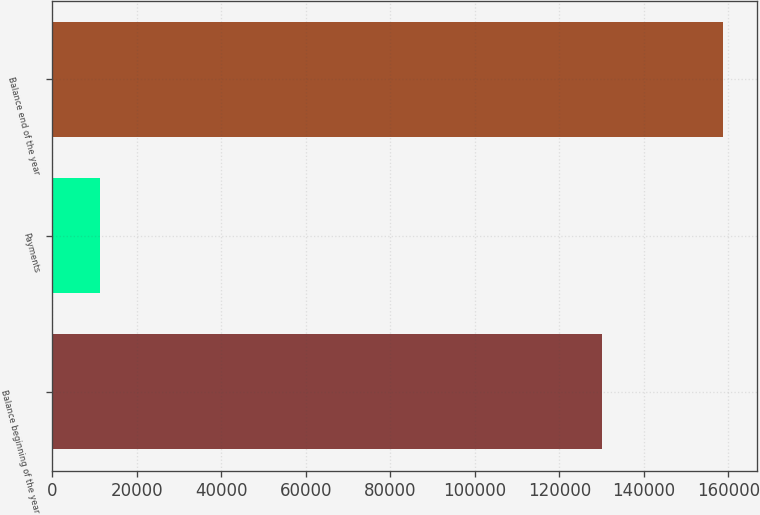Convert chart to OTSL. <chart><loc_0><loc_0><loc_500><loc_500><bar_chart><fcel>Balance beginning of the year<fcel>Payments<fcel>Balance end of the year<nl><fcel>130018<fcel>11253<fcel>158765<nl></chart> 